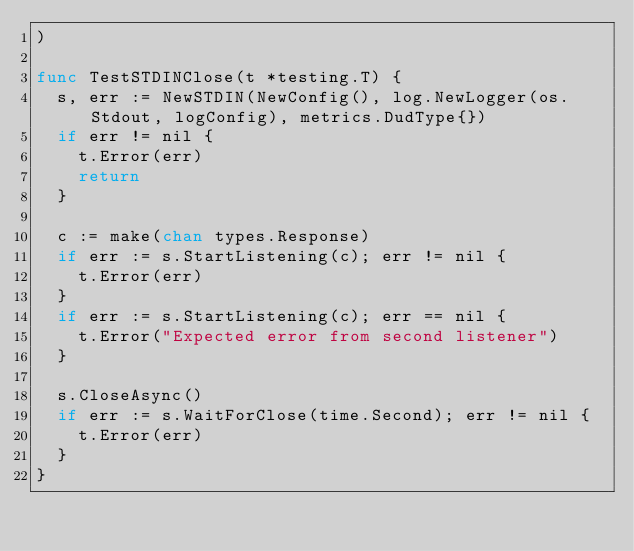<code> <loc_0><loc_0><loc_500><loc_500><_Go_>)

func TestSTDINClose(t *testing.T) {
	s, err := NewSTDIN(NewConfig(), log.NewLogger(os.Stdout, logConfig), metrics.DudType{})
	if err != nil {
		t.Error(err)
		return
	}

	c := make(chan types.Response)
	if err := s.StartListening(c); err != nil {
		t.Error(err)
	}
	if err := s.StartListening(c); err == nil {
		t.Error("Expected error from second listener")
	}

	s.CloseAsync()
	if err := s.WaitForClose(time.Second); err != nil {
		t.Error(err)
	}
}
</code> 